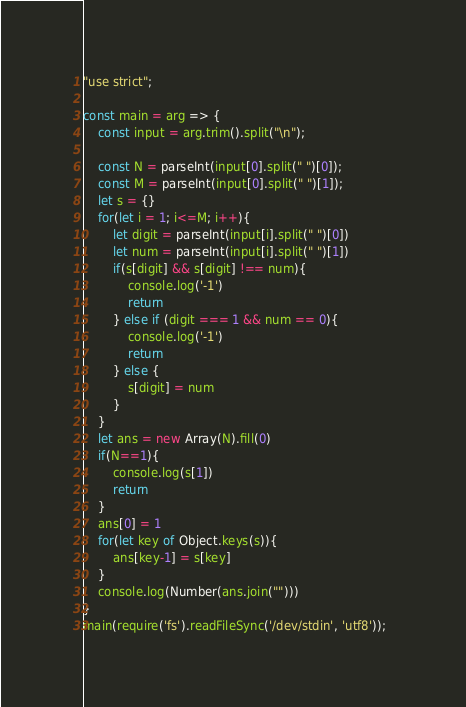Convert code to text. <code><loc_0><loc_0><loc_500><loc_500><_JavaScript_>"use strict";

const main = arg => {
    const input = arg.trim().split("\n");

    const N = parseInt(input[0].split(" ")[0]);
    const M = parseInt(input[0].split(" ")[1]);
    let s = {}
    for(let i = 1; i<=M; i++){
        let digit = parseInt(input[i].split(" ")[0])
        let num = parseInt(input[i].split(" ")[1])
        if(s[digit] && s[digit] !== num){
            console.log('-1')
            return
        } else if (digit === 1 && num == 0){
            console.log('-1')
            return
        } else {
            s[digit] = num
        }
    }
    let ans = new Array(N).fill(0)
    if(N==1){
        console.log(s[1])
        return
    }
    ans[0] = 1
    for(let key of Object.keys(s)){
        ans[key-1] = s[key]
    }
    console.log(Number(ans.join("")))
}
main(require('fs').readFileSync('/dev/stdin', 'utf8'));  </code> 